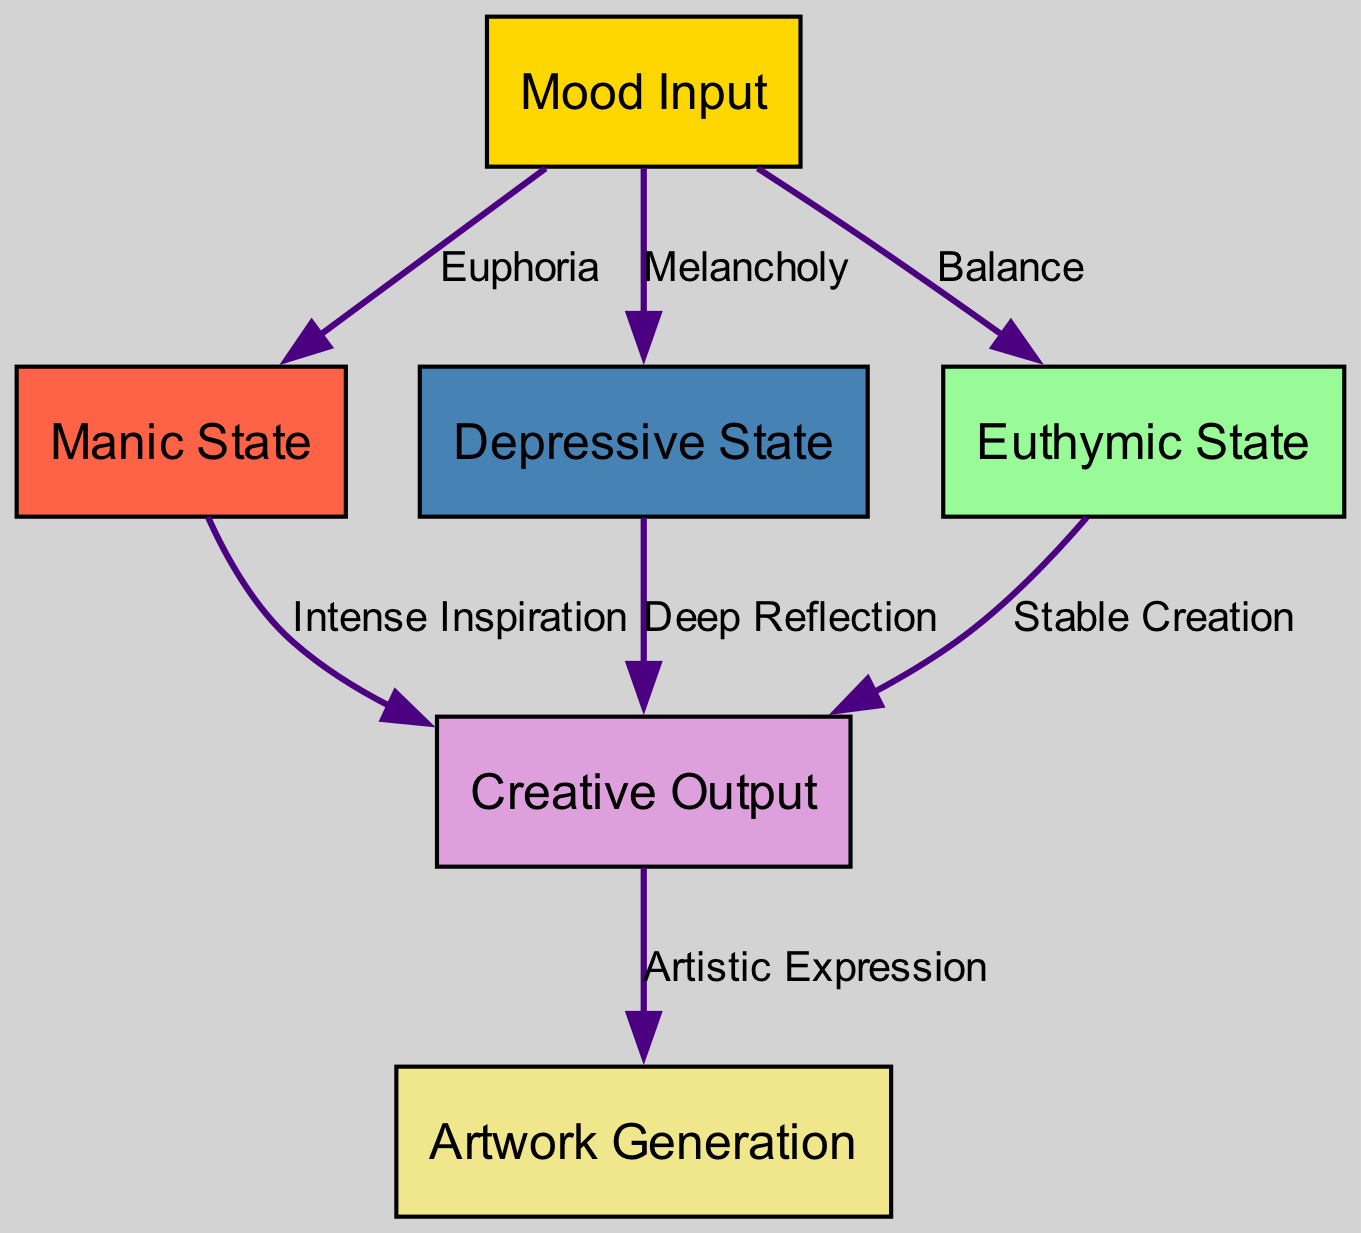What are the three emotional states represented in the diagram? The diagram contains three nodes representing emotional states: manic, depressive, and euthymic. These nodes are explicitly labeled and connected.
Answer: manic, depressive, euthymic How many total nodes are in the diagram? The diagram includes six nodes: one input node, three emotional state nodes, one creative output node, and one artwork generation node. Counting all these gives a total of six nodes.
Answer: six What is the connection label between the input and the manic state? The edge connecting the input node to the manic state node is labeled "Euphoria." This specific label is presented directly on the diagram along the connecting edge.
Answer: Euphoria How does the manic state contribute to creative output? The manic state node connects to the creative output node with an edge labeled "Intense Inspiration." This indicates that the manic state influences creativity through intense inspiration.
Answer: Intense Inspiration Which emotional state has a direct relationship with both creative output and artwork generation? The creative output node has direct edges leading to both the artwork generation node and the emotional states of manic, depressive, and euthymic, reflecting its central role in the diagram.
Answer: creative output What is the label describing the edge from the depressive state to creative output? The edge connecting the depressive state to the creative output is labeled "Deep Reflection," illustrating that this emotional state promotes creativity through a process of reflection.
Answer: Deep Reflection What is the significance of the euthymic state in this architecture? The euthymic state is connected to the creative output node with the label "Stable Creation," suggesting its role in foster balanced and consistent creativity. This connection indicates the importance of emotional stability for artistic work.
Answer: Stable Creation How many edges are present in total in this diagram? The diagram includes a total of six edges that connect the nodes together, showing the relationships between the emotional states and the creative process.
Answer: six What relationship is depicted between creative output and artwork generation? The edge from the creative output node to the artwork generation node is labeled "Artistic Expression," indicating that the creative output influences the final generation of artwork.
Answer: Artistic Expression 